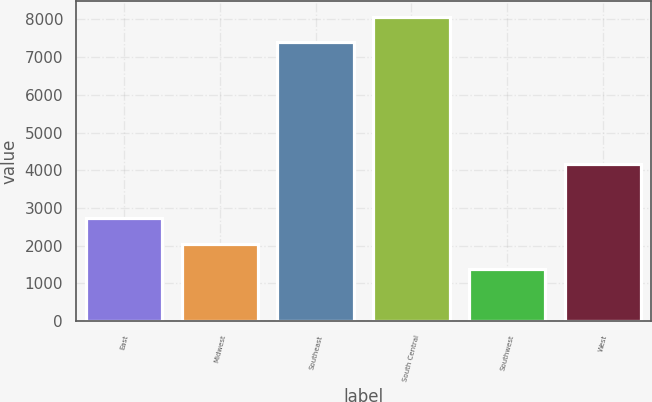<chart> <loc_0><loc_0><loc_500><loc_500><bar_chart><fcel>East<fcel>Midwest<fcel>Southeast<fcel>South Central<fcel>Southwest<fcel>West<nl><fcel>2719.6<fcel>2050.3<fcel>7408<fcel>8077.3<fcel>1381<fcel>4153<nl></chart> 